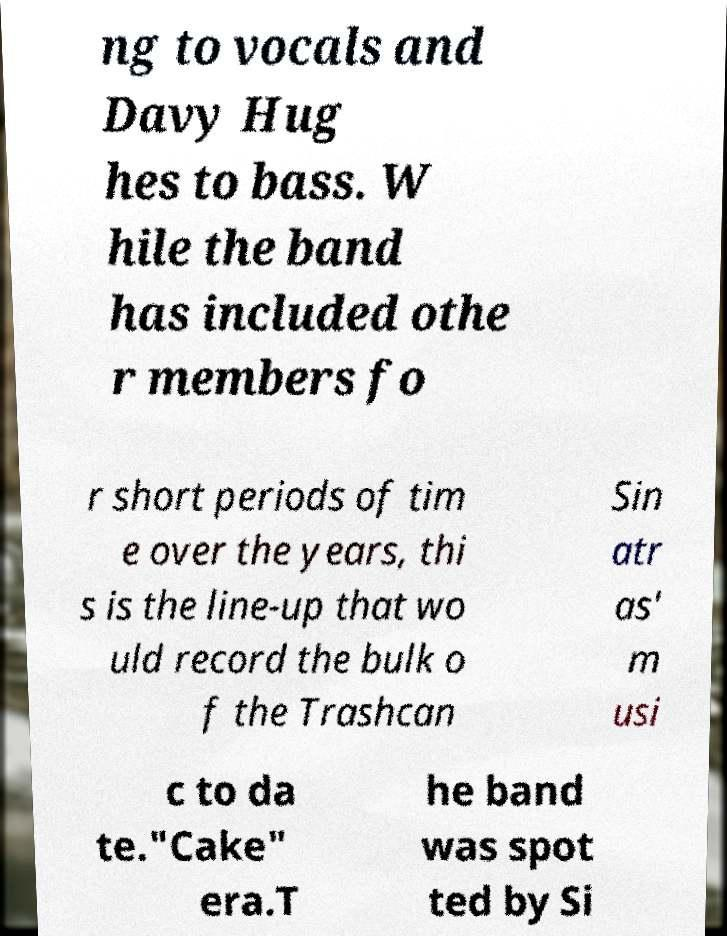Can you accurately transcribe the text from the provided image for me? ng to vocals and Davy Hug hes to bass. W hile the band has included othe r members fo r short periods of tim e over the years, thi s is the line-up that wo uld record the bulk o f the Trashcan Sin atr as' m usi c to da te."Cake" era.T he band was spot ted by Si 